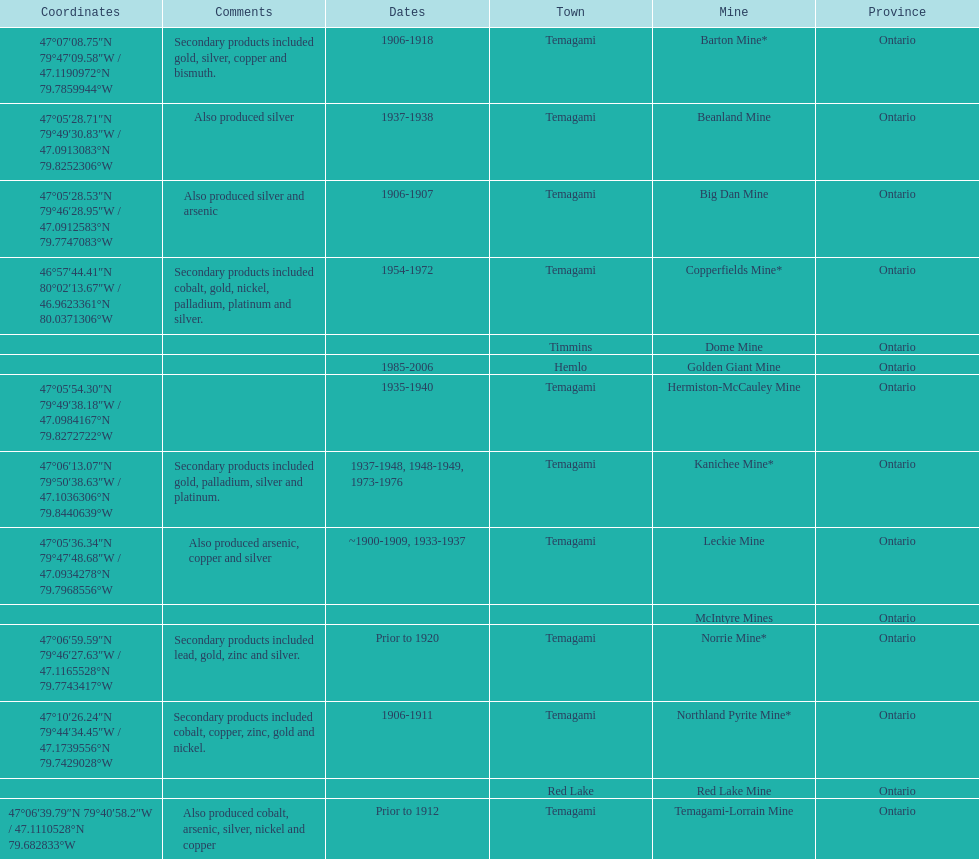Tell me the number of mines that also produced arsenic. 3. 